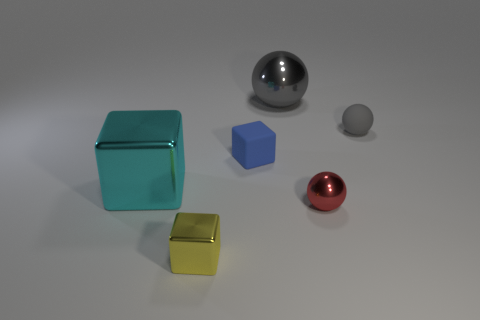Add 2 tiny yellow metallic things. How many objects exist? 8 Subtract all small rubber blocks. How many blocks are left? 2 Subtract all yellow blocks. How many blocks are left? 2 Subtract 1 cubes. How many cubes are left? 2 Add 1 gray things. How many gray things exist? 3 Subtract 0 green cylinders. How many objects are left? 6 Subtract all blue balls. Subtract all red cylinders. How many balls are left? 3 Subtract all yellow spheres. How many red cubes are left? 0 Subtract all cyan shiny cubes. Subtract all rubber spheres. How many objects are left? 4 Add 1 tiny rubber objects. How many tiny rubber objects are left? 3 